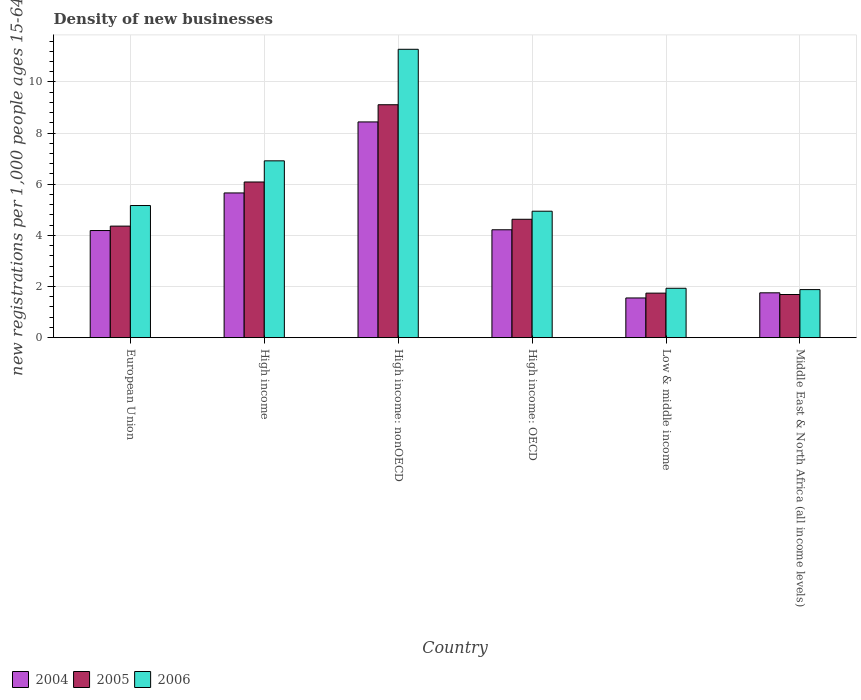How many groups of bars are there?
Your response must be concise. 6. How many bars are there on the 3rd tick from the left?
Give a very brief answer. 3. How many bars are there on the 2nd tick from the right?
Ensure brevity in your answer.  3. In how many cases, is the number of bars for a given country not equal to the number of legend labels?
Provide a succinct answer. 0. What is the number of new registrations in 2004 in European Union?
Give a very brief answer. 4.19. Across all countries, what is the maximum number of new registrations in 2006?
Provide a short and direct response. 11.28. Across all countries, what is the minimum number of new registrations in 2004?
Your answer should be very brief. 1.55. In which country was the number of new registrations in 2006 maximum?
Your answer should be very brief. High income: nonOECD. In which country was the number of new registrations in 2005 minimum?
Ensure brevity in your answer.  Middle East & North Africa (all income levels). What is the total number of new registrations in 2005 in the graph?
Offer a terse response. 27.61. What is the difference between the number of new registrations in 2005 in European Union and that in High income: OECD?
Give a very brief answer. -0.27. What is the difference between the number of new registrations in 2004 in High income: OECD and the number of new registrations in 2006 in European Union?
Make the answer very short. -0.95. What is the average number of new registrations in 2006 per country?
Ensure brevity in your answer.  5.35. What is the difference between the number of new registrations of/in 2006 and number of new registrations of/in 2004 in High income?
Give a very brief answer. 1.26. In how many countries, is the number of new registrations in 2005 greater than 4.8?
Your answer should be compact. 2. What is the ratio of the number of new registrations in 2005 in European Union to that in High income: OECD?
Keep it short and to the point. 0.94. Is the number of new registrations in 2004 in High income: nonOECD less than that in Low & middle income?
Make the answer very short. No. Is the difference between the number of new registrations in 2006 in European Union and High income: nonOECD greater than the difference between the number of new registrations in 2004 in European Union and High income: nonOECD?
Your answer should be compact. No. What is the difference between the highest and the second highest number of new registrations in 2006?
Ensure brevity in your answer.  6.11. What is the difference between the highest and the lowest number of new registrations in 2004?
Give a very brief answer. 6.88. How many countries are there in the graph?
Your response must be concise. 6. What is the difference between two consecutive major ticks on the Y-axis?
Provide a short and direct response. 2. Are the values on the major ticks of Y-axis written in scientific E-notation?
Keep it short and to the point. No. Does the graph contain grids?
Provide a short and direct response. Yes. Where does the legend appear in the graph?
Keep it short and to the point. Bottom left. How are the legend labels stacked?
Provide a short and direct response. Horizontal. What is the title of the graph?
Provide a succinct answer. Density of new businesses. Does "2012" appear as one of the legend labels in the graph?
Make the answer very short. No. What is the label or title of the Y-axis?
Ensure brevity in your answer.  New registrations per 1,0 people ages 15-64. What is the new registrations per 1,000 people ages 15-64 in 2004 in European Union?
Make the answer very short. 4.19. What is the new registrations per 1,000 people ages 15-64 in 2005 in European Union?
Give a very brief answer. 4.36. What is the new registrations per 1,000 people ages 15-64 of 2006 in European Union?
Offer a very short reply. 5.17. What is the new registrations per 1,000 people ages 15-64 of 2004 in High income?
Your answer should be very brief. 5.66. What is the new registrations per 1,000 people ages 15-64 in 2005 in High income?
Your answer should be compact. 6.09. What is the new registrations per 1,000 people ages 15-64 of 2006 in High income?
Keep it short and to the point. 6.91. What is the new registrations per 1,000 people ages 15-64 in 2004 in High income: nonOECD?
Your answer should be very brief. 8.44. What is the new registrations per 1,000 people ages 15-64 in 2005 in High income: nonOECD?
Give a very brief answer. 9.11. What is the new registrations per 1,000 people ages 15-64 in 2006 in High income: nonOECD?
Your answer should be compact. 11.28. What is the new registrations per 1,000 people ages 15-64 in 2004 in High income: OECD?
Offer a very short reply. 4.22. What is the new registrations per 1,000 people ages 15-64 of 2005 in High income: OECD?
Your answer should be compact. 4.63. What is the new registrations per 1,000 people ages 15-64 of 2006 in High income: OECD?
Keep it short and to the point. 4.94. What is the new registrations per 1,000 people ages 15-64 in 2004 in Low & middle income?
Offer a terse response. 1.55. What is the new registrations per 1,000 people ages 15-64 of 2005 in Low & middle income?
Your answer should be compact. 1.74. What is the new registrations per 1,000 people ages 15-64 in 2006 in Low & middle income?
Your answer should be very brief. 1.93. What is the new registrations per 1,000 people ages 15-64 of 2004 in Middle East & North Africa (all income levels)?
Ensure brevity in your answer.  1.75. What is the new registrations per 1,000 people ages 15-64 in 2005 in Middle East & North Africa (all income levels)?
Make the answer very short. 1.69. What is the new registrations per 1,000 people ages 15-64 in 2006 in Middle East & North Africa (all income levels)?
Provide a short and direct response. 1.88. Across all countries, what is the maximum new registrations per 1,000 people ages 15-64 in 2004?
Make the answer very short. 8.44. Across all countries, what is the maximum new registrations per 1,000 people ages 15-64 of 2005?
Your response must be concise. 9.11. Across all countries, what is the maximum new registrations per 1,000 people ages 15-64 of 2006?
Your response must be concise. 11.28. Across all countries, what is the minimum new registrations per 1,000 people ages 15-64 in 2004?
Give a very brief answer. 1.55. Across all countries, what is the minimum new registrations per 1,000 people ages 15-64 in 2005?
Ensure brevity in your answer.  1.69. Across all countries, what is the minimum new registrations per 1,000 people ages 15-64 in 2006?
Keep it short and to the point. 1.88. What is the total new registrations per 1,000 people ages 15-64 of 2004 in the graph?
Offer a very short reply. 25.81. What is the total new registrations per 1,000 people ages 15-64 in 2005 in the graph?
Give a very brief answer. 27.61. What is the total new registrations per 1,000 people ages 15-64 of 2006 in the graph?
Your answer should be very brief. 32.11. What is the difference between the new registrations per 1,000 people ages 15-64 in 2004 in European Union and that in High income?
Your answer should be very brief. -1.47. What is the difference between the new registrations per 1,000 people ages 15-64 of 2005 in European Union and that in High income?
Provide a short and direct response. -1.73. What is the difference between the new registrations per 1,000 people ages 15-64 in 2006 in European Union and that in High income?
Give a very brief answer. -1.75. What is the difference between the new registrations per 1,000 people ages 15-64 in 2004 in European Union and that in High income: nonOECD?
Provide a short and direct response. -4.25. What is the difference between the new registrations per 1,000 people ages 15-64 in 2005 in European Union and that in High income: nonOECD?
Provide a succinct answer. -4.75. What is the difference between the new registrations per 1,000 people ages 15-64 of 2006 in European Union and that in High income: nonOECD?
Give a very brief answer. -6.11. What is the difference between the new registrations per 1,000 people ages 15-64 in 2004 in European Union and that in High income: OECD?
Keep it short and to the point. -0.03. What is the difference between the new registrations per 1,000 people ages 15-64 of 2005 in European Union and that in High income: OECD?
Offer a terse response. -0.27. What is the difference between the new registrations per 1,000 people ages 15-64 of 2006 in European Union and that in High income: OECD?
Keep it short and to the point. 0.22. What is the difference between the new registrations per 1,000 people ages 15-64 in 2004 in European Union and that in Low & middle income?
Offer a very short reply. 2.64. What is the difference between the new registrations per 1,000 people ages 15-64 of 2005 in European Union and that in Low & middle income?
Keep it short and to the point. 2.62. What is the difference between the new registrations per 1,000 people ages 15-64 in 2006 in European Union and that in Low & middle income?
Keep it short and to the point. 3.24. What is the difference between the new registrations per 1,000 people ages 15-64 in 2004 in European Union and that in Middle East & North Africa (all income levels)?
Ensure brevity in your answer.  2.44. What is the difference between the new registrations per 1,000 people ages 15-64 in 2005 in European Union and that in Middle East & North Africa (all income levels)?
Offer a very short reply. 2.67. What is the difference between the new registrations per 1,000 people ages 15-64 in 2006 in European Union and that in Middle East & North Africa (all income levels)?
Keep it short and to the point. 3.29. What is the difference between the new registrations per 1,000 people ages 15-64 in 2004 in High income and that in High income: nonOECD?
Your response must be concise. -2.78. What is the difference between the new registrations per 1,000 people ages 15-64 in 2005 in High income and that in High income: nonOECD?
Offer a terse response. -3.02. What is the difference between the new registrations per 1,000 people ages 15-64 in 2006 in High income and that in High income: nonOECD?
Provide a succinct answer. -4.36. What is the difference between the new registrations per 1,000 people ages 15-64 of 2004 in High income and that in High income: OECD?
Provide a succinct answer. 1.44. What is the difference between the new registrations per 1,000 people ages 15-64 of 2005 in High income and that in High income: OECD?
Ensure brevity in your answer.  1.46. What is the difference between the new registrations per 1,000 people ages 15-64 of 2006 in High income and that in High income: OECD?
Keep it short and to the point. 1.97. What is the difference between the new registrations per 1,000 people ages 15-64 of 2004 in High income and that in Low & middle income?
Provide a succinct answer. 4.11. What is the difference between the new registrations per 1,000 people ages 15-64 in 2005 in High income and that in Low & middle income?
Make the answer very short. 4.35. What is the difference between the new registrations per 1,000 people ages 15-64 in 2006 in High income and that in Low & middle income?
Offer a very short reply. 4.98. What is the difference between the new registrations per 1,000 people ages 15-64 of 2004 in High income and that in Middle East & North Africa (all income levels)?
Provide a succinct answer. 3.91. What is the difference between the new registrations per 1,000 people ages 15-64 of 2005 in High income and that in Middle East & North Africa (all income levels)?
Ensure brevity in your answer.  4.4. What is the difference between the new registrations per 1,000 people ages 15-64 in 2006 in High income and that in Middle East & North Africa (all income levels)?
Provide a short and direct response. 5.04. What is the difference between the new registrations per 1,000 people ages 15-64 of 2004 in High income: nonOECD and that in High income: OECD?
Offer a very short reply. 4.22. What is the difference between the new registrations per 1,000 people ages 15-64 of 2005 in High income: nonOECD and that in High income: OECD?
Offer a very short reply. 4.48. What is the difference between the new registrations per 1,000 people ages 15-64 in 2006 in High income: nonOECD and that in High income: OECD?
Your answer should be very brief. 6.33. What is the difference between the new registrations per 1,000 people ages 15-64 in 2004 in High income: nonOECD and that in Low & middle income?
Offer a terse response. 6.88. What is the difference between the new registrations per 1,000 people ages 15-64 in 2005 in High income: nonOECD and that in Low & middle income?
Provide a succinct answer. 7.37. What is the difference between the new registrations per 1,000 people ages 15-64 of 2006 in High income: nonOECD and that in Low & middle income?
Give a very brief answer. 9.34. What is the difference between the new registrations per 1,000 people ages 15-64 of 2004 in High income: nonOECD and that in Middle East & North Africa (all income levels)?
Your answer should be very brief. 6.68. What is the difference between the new registrations per 1,000 people ages 15-64 of 2005 in High income: nonOECD and that in Middle East & North Africa (all income levels)?
Your response must be concise. 7.42. What is the difference between the new registrations per 1,000 people ages 15-64 in 2006 in High income: nonOECD and that in Middle East & North Africa (all income levels)?
Keep it short and to the point. 9.4. What is the difference between the new registrations per 1,000 people ages 15-64 of 2004 in High income: OECD and that in Low & middle income?
Your answer should be compact. 2.67. What is the difference between the new registrations per 1,000 people ages 15-64 in 2005 in High income: OECD and that in Low & middle income?
Give a very brief answer. 2.89. What is the difference between the new registrations per 1,000 people ages 15-64 of 2006 in High income: OECD and that in Low & middle income?
Keep it short and to the point. 3.01. What is the difference between the new registrations per 1,000 people ages 15-64 of 2004 in High income: OECD and that in Middle East & North Africa (all income levels)?
Keep it short and to the point. 2.47. What is the difference between the new registrations per 1,000 people ages 15-64 in 2005 in High income: OECD and that in Middle East & North Africa (all income levels)?
Give a very brief answer. 2.94. What is the difference between the new registrations per 1,000 people ages 15-64 of 2006 in High income: OECD and that in Middle East & North Africa (all income levels)?
Offer a terse response. 3.07. What is the difference between the new registrations per 1,000 people ages 15-64 in 2004 in Low & middle income and that in Middle East & North Africa (all income levels)?
Keep it short and to the point. -0.2. What is the difference between the new registrations per 1,000 people ages 15-64 in 2005 in Low & middle income and that in Middle East & North Africa (all income levels)?
Keep it short and to the point. 0.05. What is the difference between the new registrations per 1,000 people ages 15-64 in 2006 in Low & middle income and that in Middle East & North Africa (all income levels)?
Make the answer very short. 0.05. What is the difference between the new registrations per 1,000 people ages 15-64 in 2004 in European Union and the new registrations per 1,000 people ages 15-64 in 2005 in High income?
Provide a short and direct response. -1.9. What is the difference between the new registrations per 1,000 people ages 15-64 in 2004 in European Union and the new registrations per 1,000 people ages 15-64 in 2006 in High income?
Provide a short and direct response. -2.73. What is the difference between the new registrations per 1,000 people ages 15-64 of 2005 in European Union and the new registrations per 1,000 people ages 15-64 of 2006 in High income?
Your response must be concise. -2.55. What is the difference between the new registrations per 1,000 people ages 15-64 in 2004 in European Union and the new registrations per 1,000 people ages 15-64 in 2005 in High income: nonOECD?
Make the answer very short. -4.92. What is the difference between the new registrations per 1,000 people ages 15-64 of 2004 in European Union and the new registrations per 1,000 people ages 15-64 of 2006 in High income: nonOECD?
Keep it short and to the point. -7.09. What is the difference between the new registrations per 1,000 people ages 15-64 of 2005 in European Union and the new registrations per 1,000 people ages 15-64 of 2006 in High income: nonOECD?
Your response must be concise. -6.91. What is the difference between the new registrations per 1,000 people ages 15-64 in 2004 in European Union and the new registrations per 1,000 people ages 15-64 in 2005 in High income: OECD?
Your answer should be very brief. -0.44. What is the difference between the new registrations per 1,000 people ages 15-64 of 2004 in European Union and the new registrations per 1,000 people ages 15-64 of 2006 in High income: OECD?
Ensure brevity in your answer.  -0.76. What is the difference between the new registrations per 1,000 people ages 15-64 in 2005 in European Union and the new registrations per 1,000 people ages 15-64 in 2006 in High income: OECD?
Give a very brief answer. -0.58. What is the difference between the new registrations per 1,000 people ages 15-64 of 2004 in European Union and the new registrations per 1,000 people ages 15-64 of 2005 in Low & middle income?
Make the answer very short. 2.45. What is the difference between the new registrations per 1,000 people ages 15-64 of 2004 in European Union and the new registrations per 1,000 people ages 15-64 of 2006 in Low & middle income?
Your answer should be very brief. 2.26. What is the difference between the new registrations per 1,000 people ages 15-64 of 2005 in European Union and the new registrations per 1,000 people ages 15-64 of 2006 in Low & middle income?
Provide a short and direct response. 2.43. What is the difference between the new registrations per 1,000 people ages 15-64 in 2004 in European Union and the new registrations per 1,000 people ages 15-64 in 2005 in Middle East & North Africa (all income levels)?
Your answer should be very brief. 2.5. What is the difference between the new registrations per 1,000 people ages 15-64 of 2004 in European Union and the new registrations per 1,000 people ages 15-64 of 2006 in Middle East & North Africa (all income levels)?
Your answer should be very brief. 2.31. What is the difference between the new registrations per 1,000 people ages 15-64 of 2005 in European Union and the new registrations per 1,000 people ages 15-64 of 2006 in Middle East & North Africa (all income levels)?
Ensure brevity in your answer.  2.48. What is the difference between the new registrations per 1,000 people ages 15-64 of 2004 in High income and the new registrations per 1,000 people ages 15-64 of 2005 in High income: nonOECD?
Ensure brevity in your answer.  -3.45. What is the difference between the new registrations per 1,000 people ages 15-64 in 2004 in High income and the new registrations per 1,000 people ages 15-64 in 2006 in High income: nonOECD?
Your answer should be compact. -5.62. What is the difference between the new registrations per 1,000 people ages 15-64 of 2005 in High income and the new registrations per 1,000 people ages 15-64 of 2006 in High income: nonOECD?
Your response must be concise. -5.19. What is the difference between the new registrations per 1,000 people ages 15-64 in 2004 in High income and the new registrations per 1,000 people ages 15-64 in 2005 in High income: OECD?
Keep it short and to the point. 1.03. What is the difference between the new registrations per 1,000 people ages 15-64 of 2004 in High income and the new registrations per 1,000 people ages 15-64 of 2006 in High income: OECD?
Your response must be concise. 0.71. What is the difference between the new registrations per 1,000 people ages 15-64 in 2005 in High income and the new registrations per 1,000 people ages 15-64 in 2006 in High income: OECD?
Your response must be concise. 1.14. What is the difference between the new registrations per 1,000 people ages 15-64 of 2004 in High income and the new registrations per 1,000 people ages 15-64 of 2005 in Low & middle income?
Offer a terse response. 3.92. What is the difference between the new registrations per 1,000 people ages 15-64 of 2004 in High income and the new registrations per 1,000 people ages 15-64 of 2006 in Low & middle income?
Offer a terse response. 3.73. What is the difference between the new registrations per 1,000 people ages 15-64 in 2005 in High income and the new registrations per 1,000 people ages 15-64 in 2006 in Low & middle income?
Provide a short and direct response. 4.16. What is the difference between the new registrations per 1,000 people ages 15-64 in 2004 in High income and the new registrations per 1,000 people ages 15-64 in 2005 in Middle East & North Africa (all income levels)?
Provide a short and direct response. 3.97. What is the difference between the new registrations per 1,000 people ages 15-64 of 2004 in High income and the new registrations per 1,000 people ages 15-64 of 2006 in Middle East & North Africa (all income levels)?
Provide a succinct answer. 3.78. What is the difference between the new registrations per 1,000 people ages 15-64 in 2005 in High income and the new registrations per 1,000 people ages 15-64 in 2006 in Middle East & North Africa (all income levels)?
Offer a terse response. 4.21. What is the difference between the new registrations per 1,000 people ages 15-64 in 2004 in High income: nonOECD and the new registrations per 1,000 people ages 15-64 in 2005 in High income: OECD?
Give a very brief answer. 3.81. What is the difference between the new registrations per 1,000 people ages 15-64 in 2004 in High income: nonOECD and the new registrations per 1,000 people ages 15-64 in 2006 in High income: OECD?
Your answer should be very brief. 3.49. What is the difference between the new registrations per 1,000 people ages 15-64 in 2005 in High income: nonOECD and the new registrations per 1,000 people ages 15-64 in 2006 in High income: OECD?
Give a very brief answer. 4.16. What is the difference between the new registrations per 1,000 people ages 15-64 of 2004 in High income: nonOECD and the new registrations per 1,000 people ages 15-64 of 2005 in Low & middle income?
Offer a very short reply. 6.69. What is the difference between the new registrations per 1,000 people ages 15-64 of 2004 in High income: nonOECD and the new registrations per 1,000 people ages 15-64 of 2006 in Low & middle income?
Offer a terse response. 6.5. What is the difference between the new registrations per 1,000 people ages 15-64 of 2005 in High income: nonOECD and the new registrations per 1,000 people ages 15-64 of 2006 in Low & middle income?
Offer a very short reply. 7.18. What is the difference between the new registrations per 1,000 people ages 15-64 of 2004 in High income: nonOECD and the new registrations per 1,000 people ages 15-64 of 2005 in Middle East & North Africa (all income levels)?
Ensure brevity in your answer.  6.75. What is the difference between the new registrations per 1,000 people ages 15-64 in 2004 in High income: nonOECD and the new registrations per 1,000 people ages 15-64 in 2006 in Middle East & North Africa (all income levels)?
Make the answer very short. 6.56. What is the difference between the new registrations per 1,000 people ages 15-64 in 2005 in High income: nonOECD and the new registrations per 1,000 people ages 15-64 in 2006 in Middle East & North Africa (all income levels)?
Your answer should be very brief. 7.23. What is the difference between the new registrations per 1,000 people ages 15-64 of 2004 in High income: OECD and the new registrations per 1,000 people ages 15-64 of 2005 in Low & middle income?
Your answer should be very brief. 2.48. What is the difference between the new registrations per 1,000 people ages 15-64 in 2004 in High income: OECD and the new registrations per 1,000 people ages 15-64 in 2006 in Low & middle income?
Your answer should be very brief. 2.29. What is the difference between the new registrations per 1,000 people ages 15-64 in 2005 in High income: OECD and the new registrations per 1,000 people ages 15-64 in 2006 in Low & middle income?
Offer a very short reply. 2.7. What is the difference between the new registrations per 1,000 people ages 15-64 in 2004 in High income: OECD and the new registrations per 1,000 people ages 15-64 in 2005 in Middle East & North Africa (all income levels)?
Make the answer very short. 2.53. What is the difference between the new registrations per 1,000 people ages 15-64 in 2004 in High income: OECD and the new registrations per 1,000 people ages 15-64 in 2006 in Middle East & North Africa (all income levels)?
Ensure brevity in your answer.  2.34. What is the difference between the new registrations per 1,000 people ages 15-64 in 2005 in High income: OECD and the new registrations per 1,000 people ages 15-64 in 2006 in Middle East & North Africa (all income levels)?
Give a very brief answer. 2.75. What is the difference between the new registrations per 1,000 people ages 15-64 in 2004 in Low & middle income and the new registrations per 1,000 people ages 15-64 in 2005 in Middle East & North Africa (all income levels)?
Your response must be concise. -0.13. What is the difference between the new registrations per 1,000 people ages 15-64 in 2004 in Low & middle income and the new registrations per 1,000 people ages 15-64 in 2006 in Middle East & North Africa (all income levels)?
Keep it short and to the point. -0.33. What is the difference between the new registrations per 1,000 people ages 15-64 of 2005 in Low & middle income and the new registrations per 1,000 people ages 15-64 of 2006 in Middle East & North Africa (all income levels)?
Provide a succinct answer. -0.14. What is the average new registrations per 1,000 people ages 15-64 of 2004 per country?
Your response must be concise. 4.3. What is the average new registrations per 1,000 people ages 15-64 of 2005 per country?
Keep it short and to the point. 4.6. What is the average new registrations per 1,000 people ages 15-64 of 2006 per country?
Provide a succinct answer. 5.35. What is the difference between the new registrations per 1,000 people ages 15-64 in 2004 and new registrations per 1,000 people ages 15-64 in 2005 in European Union?
Make the answer very short. -0.17. What is the difference between the new registrations per 1,000 people ages 15-64 in 2004 and new registrations per 1,000 people ages 15-64 in 2006 in European Union?
Ensure brevity in your answer.  -0.98. What is the difference between the new registrations per 1,000 people ages 15-64 of 2005 and new registrations per 1,000 people ages 15-64 of 2006 in European Union?
Ensure brevity in your answer.  -0.81. What is the difference between the new registrations per 1,000 people ages 15-64 in 2004 and new registrations per 1,000 people ages 15-64 in 2005 in High income?
Offer a terse response. -0.43. What is the difference between the new registrations per 1,000 people ages 15-64 of 2004 and new registrations per 1,000 people ages 15-64 of 2006 in High income?
Offer a very short reply. -1.26. What is the difference between the new registrations per 1,000 people ages 15-64 of 2005 and new registrations per 1,000 people ages 15-64 of 2006 in High income?
Offer a terse response. -0.83. What is the difference between the new registrations per 1,000 people ages 15-64 in 2004 and new registrations per 1,000 people ages 15-64 in 2005 in High income: nonOECD?
Make the answer very short. -0.67. What is the difference between the new registrations per 1,000 people ages 15-64 in 2004 and new registrations per 1,000 people ages 15-64 in 2006 in High income: nonOECD?
Your answer should be compact. -2.84. What is the difference between the new registrations per 1,000 people ages 15-64 of 2005 and new registrations per 1,000 people ages 15-64 of 2006 in High income: nonOECD?
Give a very brief answer. -2.17. What is the difference between the new registrations per 1,000 people ages 15-64 in 2004 and new registrations per 1,000 people ages 15-64 in 2005 in High income: OECD?
Keep it short and to the point. -0.41. What is the difference between the new registrations per 1,000 people ages 15-64 of 2004 and new registrations per 1,000 people ages 15-64 of 2006 in High income: OECD?
Your answer should be very brief. -0.73. What is the difference between the new registrations per 1,000 people ages 15-64 in 2005 and new registrations per 1,000 people ages 15-64 in 2006 in High income: OECD?
Make the answer very short. -0.32. What is the difference between the new registrations per 1,000 people ages 15-64 of 2004 and new registrations per 1,000 people ages 15-64 of 2005 in Low & middle income?
Your response must be concise. -0.19. What is the difference between the new registrations per 1,000 people ages 15-64 in 2004 and new registrations per 1,000 people ages 15-64 in 2006 in Low & middle income?
Offer a terse response. -0.38. What is the difference between the new registrations per 1,000 people ages 15-64 in 2005 and new registrations per 1,000 people ages 15-64 in 2006 in Low & middle income?
Your response must be concise. -0.19. What is the difference between the new registrations per 1,000 people ages 15-64 in 2004 and new registrations per 1,000 people ages 15-64 in 2005 in Middle East & North Africa (all income levels)?
Give a very brief answer. 0.07. What is the difference between the new registrations per 1,000 people ages 15-64 in 2004 and new registrations per 1,000 people ages 15-64 in 2006 in Middle East & North Africa (all income levels)?
Offer a terse response. -0.13. What is the difference between the new registrations per 1,000 people ages 15-64 in 2005 and new registrations per 1,000 people ages 15-64 in 2006 in Middle East & North Africa (all income levels)?
Your answer should be very brief. -0.19. What is the ratio of the new registrations per 1,000 people ages 15-64 of 2004 in European Union to that in High income?
Your response must be concise. 0.74. What is the ratio of the new registrations per 1,000 people ages 15-64 in 2005 in European Union to that in High income?
Make the answer very short. 0.72. What is the ratio of the new registrations per 1,000 people ages 15-64 in 2006 in European Union to that in High income?
Make the answer very short. 0.75. What is the ratio of the new registrations per 1,000 people ages 15-64 in 2004 in European Union to that in High income: nonOECD?
Keep it short and to the point. 0.5. What is the ratio of the new registrations per 1,000 people ages 15-64 of 2005 in European Union to that in High income: nonOECD?
Your answer should be compact. 0.48. What is the ratio of the new registrations per 1,000 people ages 15-64 of 2006 in European Union to that in High income: nonOECD?
Your answer should be very brief. 0.46. What is the ratio of the new registrations per 1,000 people ages 15-64 of 2005 in European Union to that in High income: OECD?
Offer a terse response. 0.94. What is the ratio of the new registrations per 1,000 people ages 15-64 of 2006 in European Union to that in High income: OECD?
Offer a terse response. 1.04. What is the ratio of the new registrations per 1,000 people ages 15-64 in 2004 in European Union to that in Low & middle income?
Your response must be concise. 2.7. What is the ratio of the new registrations per 1,000 people ages 15-64 of 2005 in European Union to that in Low & middle income?
Provide a succinct answer. 2.51. What is the ratio of the new registrations per 1,000 people ages 15-64 of 2006 in European Union to that in Low & middle income?
Your response must be concise. 2.68. What is the ratio of the new registrations per 1,000 people ages 15-64 of 2004 in European Union to that in Middle East & North Africa (all income levels)?
Your answer should be compact. 2.39. What is the ratio of the new registrations per 1,000 people ages 15-64 in 2005 in European Union to that in Middle East & North Africa (all income levels)?
Make the answer very short. 2.59. What is the ratio of the new registrations per 1,000 people ages 15-64 in 2006 in European Union to that in Middle East & North Africa (all income levels)?
Keep it short and to the point. 2.75. What is the ratio of the new registrations per 1,000 people ages 15-64 of 2004 in High income to that in High income: nonOECD?
Your answer should be very brief. 0.67. What is the ratio of the new registrations per 1,000 people ages 15-64 of 2005 in High income to that in High income: nonOECD?
Offer a terse response. 0.67. What is the ratio of the new registrations per 1,000 people ages 15-64 in 2006 in High income to that in High income: nonOECD?
Your answer should be very brief. 0.61. What is the ratio of the new registrations per 1,000 people ages 15-64 of 2004 in High income to that in High income: OECD?
Offer a very short reply. 1.34. What is the ratio of the new registrations per 1,000 people ages 15-64 in 2005 in High income to that in High income: OECD?
Offer a terse response. 1.31. What is the ratio of the new registrations per 1,000 people ages 15-64 of 2006 in High income to that in High income: OECD?
Your answer should be very brief. 1.4. What is the ratio of the new registrations per 1,000 people ages 15-64 in 2004 in High income to that in Low & middle income?
Your answer should be compact. 3.64. What is the ratio of the new registrations per 1,000 people ages 15-64 in 2005 in High income to that in Low & middle income?
Ensure brevity in your answer.  3.5. What is the ratio of the new registrations per 1,000 people ages 15-64 of 2006 in High income to that in Low & middle income?
Provide a short and direct response. 3.58. What is the ratio of the new registrations per 1,000 people ages 15-64 in 2004 in High income to that in Middle East & North Africa (all income levels)?
Provide a succinct answer. 3.23. What is the ratio of the new registrations per 1,000 people ages 15-64 in 2005 in High income to that in Middle East & North Africa (all income levels)?
Your answer should be very brief. 3.61. What is the ratio of the new registrations per 1,000 people ages 15-64 of 2006 in High income to that in Middle East & North Africa (all income levels)?
Offer a terse response. 3.68. What is the ratio of the new registrations per 1,000 people ages 15-64 in 2004 in High income: nonOECD to that in High income: OECD?
Provide a succinct answer. 2. What is the ratio of the new registrations per 1,000 people ages 15-64 in 2005 in High income: nonOECD to that in High income: OECD?
Provide a succinct answer. 1.97. What is the ratio of the new registrations per 1,000 people ages 15-64 in 2006 in High income: nonOECD to that in High income: OECD?
Keep it short and to the point. 2.28. What is the ratio of the new registrations per 1,000 people ages 15-64 in 2004 in High income: nonOECD to that in Low & middle income?
Offer a terse response. 5.43. What is the ratio of the new registrations per 1,000 people ages 15-64 in 2005 in High income: nonOECD to that in Low & middle income?
Your answer should be very brief. 5.23. What is the ratio of the new registrations per 1,000 people ages 15-64 of 2006 in High income: nonOECD to that in Low & middle income?
Offer a very short reply. 5.84. What is the ratio of the new registrations per 1,000 people ages 15-64 of 2004 in High income: nonOECD to that in Middle East & North Africa (all income levels)?
Provide a short and direct response. 4.81. What is the ratio of the new registrations per 1,000 people ages 15-64 of 2005 in High income: nonOECD to that in Middle East & North Africa (all income levels)?
Provide a short and direct response. 5.4. What is the ratio of the new registrations per 1,000 people ages 15-64 in 2006 in High income: nonOECD to that in Middle East & North Africa (all income levels)?
Give a very brief answer. 6. What is the ratio of the new registrations per 1,000 people ages 15-64 in 2004 in High income: OECD to that in Low & middle income?
Your answer should be compact. 2.72. What is the ratio of the new registrations per 1,000 people ages 15-64 of 2005 in High income: OECD to that in Low & middle income?
Make the answer very short. 2.66. What is the ratio of the new registrations per 1,000 people ages 15-64 in 2006 in High income: OECD to that in Low & middle income?
Offer a very short reply. 2.56. What is the ratio of the new registrations per 1,000 people ages 15-64 of 2004 in High income: OECD to that in Middle East & North Africa (all income levels)?
Ensure brevity in your answer.  2.41. What is the ratio of the new registrations per 1,000 people ages 15-64 in 2005 in High income: OECD to that in Middle East & North Africa (all income levels)?
Ensure brevity in your answer.  2.74. What is the ratio of the new registrations per 1,000 people ages 15-64 in 2006 in High income: OECD to that in Middle East & North Africa (all income levels)?
Your response must be concise. 2.63. What is the ratio of the new registrations per 1,000 people ages 15-64 of 2004 in Low & middle income to that in Middle East & North Africa (all income levels)?
Offer a very short reply. 0.89. What is the ratio of the new registrations per 1,000 people ages 15-64 in 2005 in Low & middle income to that in Middle East & North Africa (all income levels)?
Offer a terse response. 1.03. What is the ratio of the new registrations per 1,000 people ages 15-64 of 2006 in Low & middle income to that in Middle East & North Africa (all income levels)?
Your answer should be compact. 1.03. What is the difference between the highest and the second highest new registrations per 1,000 people ages 15-64 of 2004?
Offer a very short reply. 2.78. What is the difference between the highest and the second highest new registrations per 1,000 people ages 15-64 in 2005?
Provide a succinct answer. 3.02. What is the difference between the highest and the second highest new registrations per 1,000 people ages 15-64 of 2006?
Offer a terse response. 4.36. What is the difference between the highest and the lowest new registrations per 1,000 people ages 15-64 in 2004?
Offer a terse response. 6.88. What is the difference between the highest and the lowest new registrations per 1,000 people ages 15-64 of 2005?
Provide a short and direct response. 7.42. What is the difference between the highest and the lowest new registrations per 1,000 people ages 15-64 of 2006?
Your response must be concise. 9.4. 